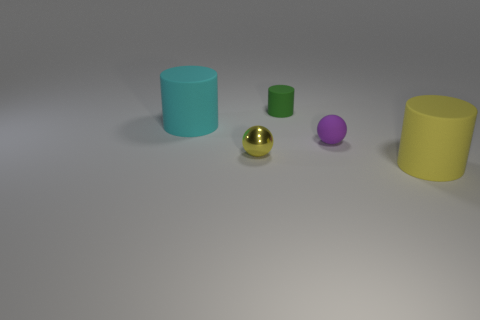Are the object right of the small matte sphere and the tiny green cylinder made of the same material?
Give a very brief answer. Yes. What is the size of the yellow object on the left side of the large cylinder to the right of the rubber cylinder left of the metallic thing?
Your answer should be compact. Small. How many other things are the same color as the small metal ball?
Your response must be concise. 1. The purple matte thing that is the same size as the yellow metallic ball is what shape?
Provide a succinct answer. Sphere. What is the size of the cylinder left of the tiny green cylinder?
Offer a very short reply. Large. There is a rubber cylinder that is in front of the tiny yellow shiny thing; is it the same color as the tiny ball that is left of the green matte cylinder?
Give a very brief answer. Yes. There is a yellow object to the left of the small rubber thing behind the big object left of the big yellow matte object; what is its material?
Offer a very short reply. Metal. Is there a cylinder that has the same size as the purple thing?
Offer a terse response. Yes. There is a yellow sphere that is the same size as the purple sphere; what is it made of?
Provide a short and direct response. Metal. There is a large rubber thing to the left of the tiny green object; what shape is it?
Offer a very short reply. Cylinder. 